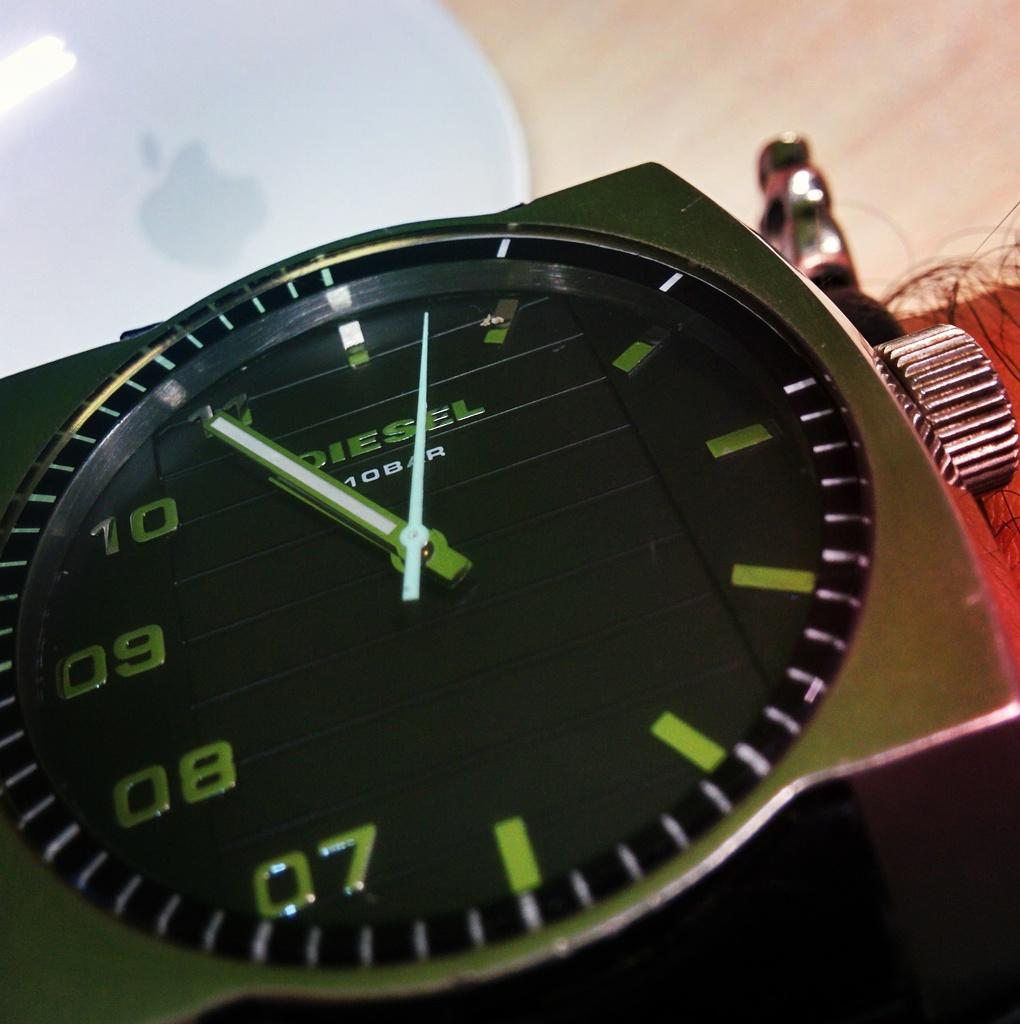Provide a one-sentence caption for the provided image. A Diesel brand watch on a hairy man's wrist. 